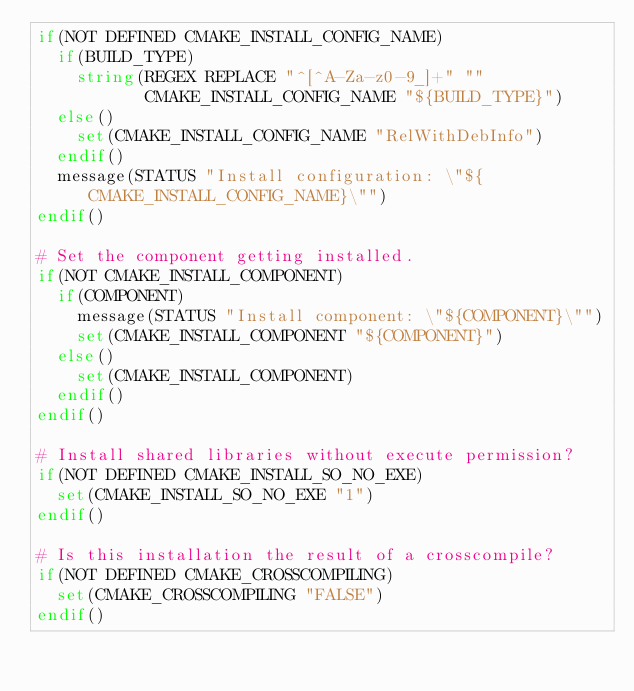Convert code to text. <code><loc_0><loc_0><loc_500><loc_500><_CMake_>if(NOT DEFINED CMAKE_INSTALL_CONFIG_NAME)
  if(BUILD_TYPE)
    string(REGEX REPLACE "^[^A-Za-z0-9_]+" ""
           CMAKE_INSTALL_CONFIG_NAME "${BUILD_TYPE}")
  else()
    set(CMAKE_INSTALL_CONFIG_NAME "RelWithDebInfo")
  endif()
  message(STATUS "Install configuration: \"${CMAKE_INSTALL_CONFIG_NAME}\"")
endif()

# Set the component getting installed.
if(NOT CMAKE_INSTALL_COMPONENT)
  if(COMPONENT)
    message(STATUS "Install component: \"${COMPONENT}\"")
    set(CMAKE_INSTALL_COMPONENT "${COMPONENT}")
  else()
    set(CMAKE_INSTALL_COMPONENT)
  endif()
endif()

# Install shared libraries without execute permission?
if(NOT DEFINED CMAKE_INSTALL_SO_NO_EXE)
  set(CMAKE_INSTALL_SO_NO_EXE "1")
endif()

# Is this installation the result of a crosscompile?
if(NOT DEFINED CMAKE_CROSSCOMPILING)
  set(CMAKE_CROSSCOMPILING "FALSE")
endif()

</code> 